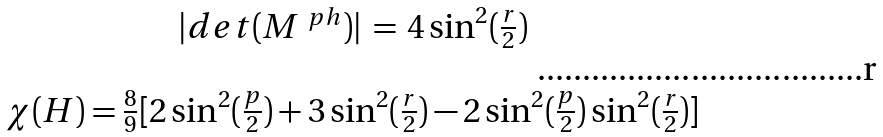Convert formula to latex. <formula><loc_0><loc_0><loc_500><loc_500>\begin{array} { c } | d e t ( M ^ { \ p h } ) | \, = \, 4 \sin ^ { 2 } ( \frac { r } { 2 } ) \\ \\ \chi ( H ) = \frac { 8 } { 9 } [ 2 \sin ^ { 2 } ( \frac { p } { 2 } ) + 3 \sin ^ { 2 } ( \frac { r } { 2 } ) - 2 \sin ^ { 2 } ( \frac { p } { 2 } ) \sin ^ { 2 } ( \frac { r } { 2 } ) ] \end{array}</formula> 